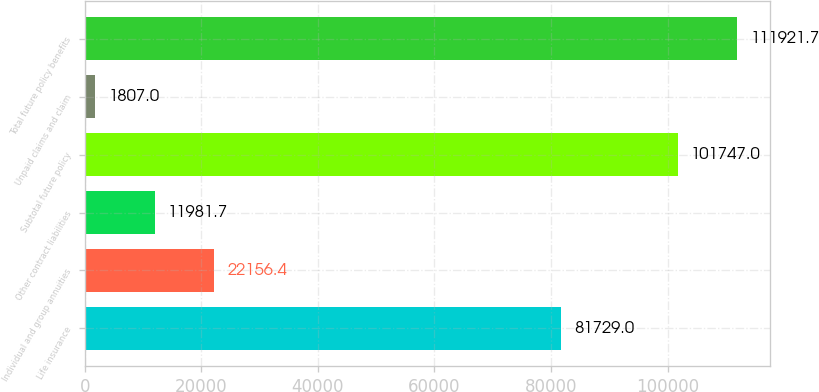<chart> <loc_0><loc_0><loc_500><loc_500><bar_chart><fcel>Life insurance<fcel>Individual and group annuities<fcel>Other contract liabilities<fcel>Subtotal future policy<fcel>Unpaid claims and claim<fcel>Total future policy benefits<nl><fcel>81729<fcel>22156.4<fcel>11981.7<fcel>101747<fcel>1807<fcel>111922<nl></chart> 